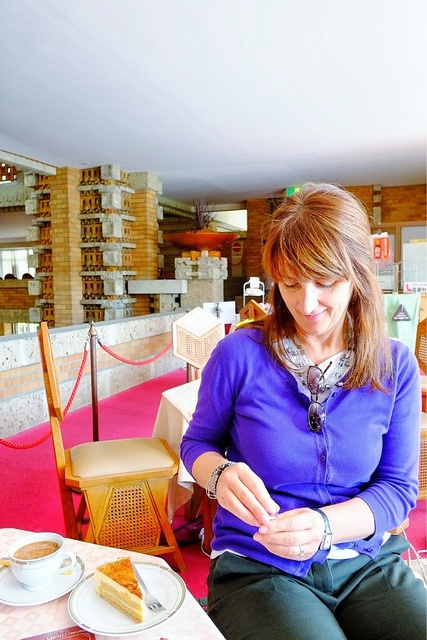Describe the objects in this image and their specific colors. I can see people in lavender, black, blue, lightgray, and lightpink tones, dining table in lavender, white, and tan tones, chair in lavender, tan, red, brown, and orange tones, cup in lavender, white, and tan tones, and cake in lavender, khaki, orange, and tan tones in this image. 